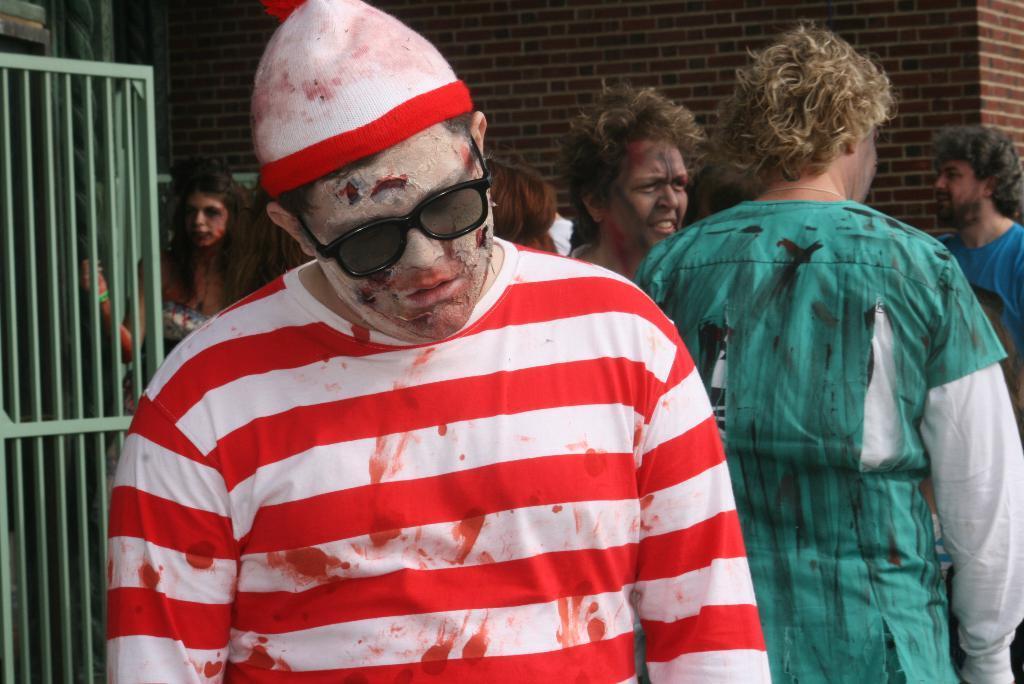Can you describe this image briefly? Here we can see people and grill. Background there is a brick wall. This man wore a cap and goggles. 